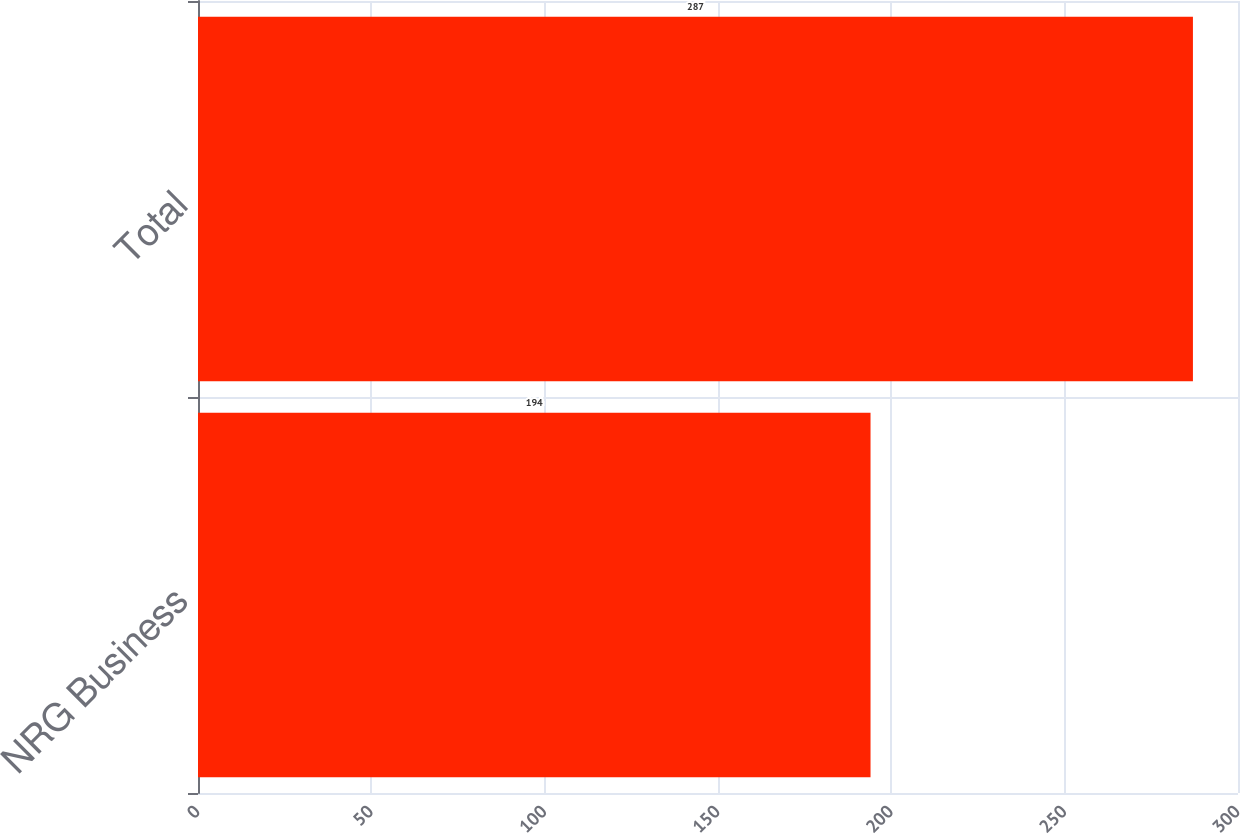<chart> <loc_0><loc_0><loc_500><loc_500><bar_chart><fcel>NRG Business<fcel>Total<nl><fcel>194<fcel>287<nl></chart> 